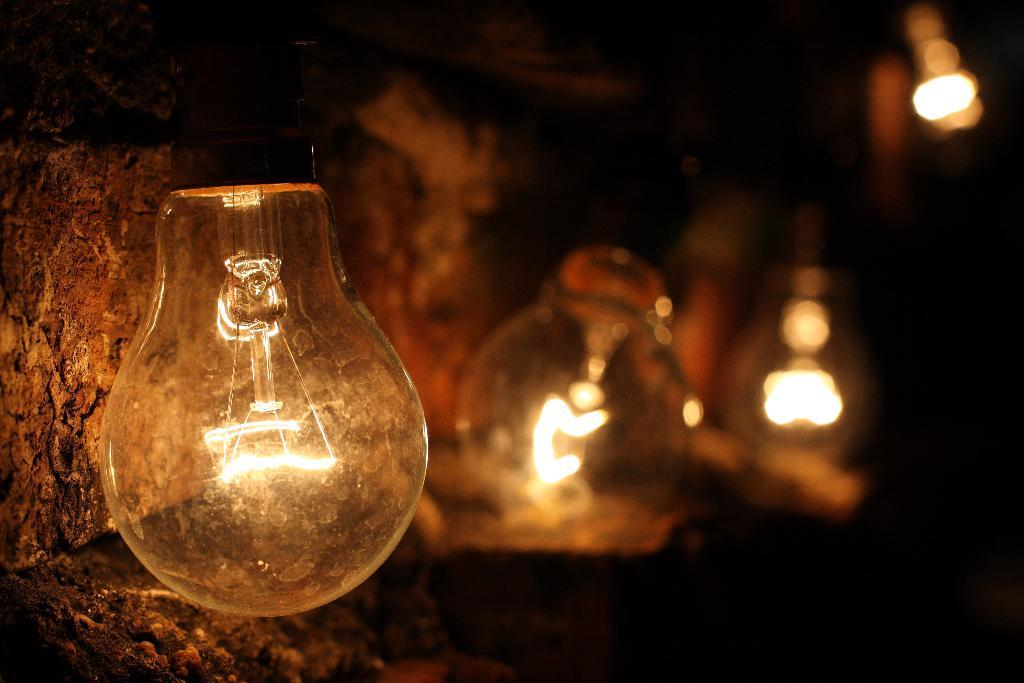What is glowing in the image? There are bulbs glowing in the image. Can you describe the location of the wall in the image? There is a wall in the left corner of the image. How many sisters are sitting on the wall in the image? There are no sisters present in the image; it only features glowing bulbs and a wall. Can you see any frogs hopping on the wall in the image? There are no frogs present in the image; it only features glowing bulbs and a wall. 